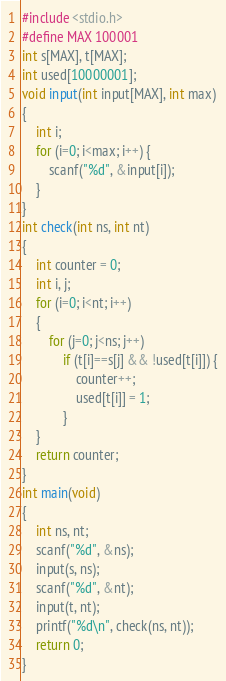Convert code to text. <code><loc_0><loc_0><loc_500><loc_500><_C_>#include <stdio.h>
#define MAX 100001
int s[MAX], t[MAX];
int used[10000001];
void input(int input[MAX], int max)
{
    int i;
    for (i=0; i<max; i++) {
        scanf("%d", &input[i]);
    }
}
int check(int ns, int nt)
{
    int counter = 0;
    int i, j;
    for (i=0; i<nt; i++)
    {
        for (j=0; j<ns; j++)
            if (t[i]==s[j] && !used[t[i]]) {
                counter++;
                used[t[i]] = 1;
            }
    }
    return counter;
}
int main(void)
{
    int ns, nt;
    scanf("%d", &ns);
    input(s, ns);
    scanf("%d", &nt);
    input(t, nt);
    printf("%d\n", check(ns, nt));
    return 0;
}</code> 